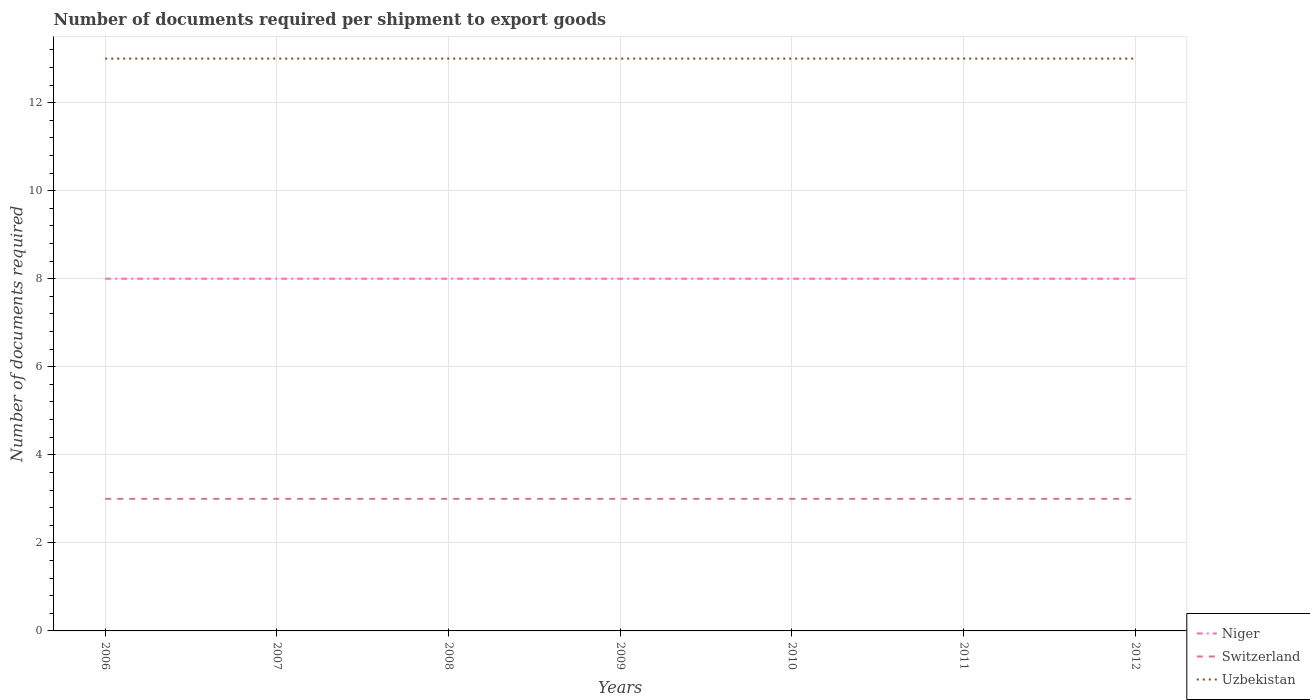How many different coloured lines are there?
Your answer should be compact. 3. Does the line corresponding to Uzbekistan intersect with the line corresponding to Switzerland?
Your response must be concise. No. Is the number of lines equal to the number of legend labels?
Your answer should be very brief. Yes. Across all years, what is the maximum number of documents required per shipment to export goods in Niger?
Ensure brevity in your answer.  8. In which year was the number of documents required per shipment to export goods in Switzerland maximum?
Offer a very short reply. 2006. What is the difference between the highest and the second highest number of documents required per shipment to export goods in Uzbekistan?
Your answer should be compact. 0. How many years are there in the graph?
Your response must be concise. 7. What is the difference between two consecutive major ticks on the Y-axis?
Provide a short and direct response. 2. Does the graph contain grids?
Your answer should be very brief. Yes. How many legend labels are there?
Offer a terse response. 3. What is the title of the graph?
Make the answer very short. Number of documents required per shipment to export goods. Does "Fragile and conflict affected situations" appear as one of the legend labels in the graph?
Offer a terse response. No. What is the label or title of the X-axis?
Provide a short and direct response. Years. What is the label or title of the Y-axis?
Your response must be concise. Number of documents required. What is the Number of documents required of Switzerland in 2006?
Provide a succinct answer. 3. What is the Number of documents required of Niger in 2008?
Offer a terse response. 8. What is the Number of documents required in Switzerland in 2008?
Offer a terse response. 3. What is the Number of documents required of Uzbekistan in 2009?
Your answer should be compact. 13. What is the Number of documents required in Niger in 2010?
Make the answer very short. 8. What is the Number of documents required of Switzerland in 2010?
Ensure brevity in your answer.  3. What is the Number of documents required in Uzbekistan in 2010?
Your answer should be very brief. 13. What is the Number of documents required in Niger in 2011?
Make the answer very short. 8. What is the Number of documents required in Switzerland in 2011?
Your answer should be very brief. 3. What is the Number of documents required in Niger in 2012?
Offer a terse response. 8. What is the Number of documents required of Uzbekistan in 2012?
Your response must be concise. 13. Across all years, what is the maximum Number of documents required of Niger?
Offer a terse response. 8. Across all years, what is the maximum Number of documents required of Uzbekistan?
Provide a short and direct response. 13. Across all years, what is the minimum Number of documents required in Niger?
Your answer should be compact. 8. Across all years, what is the minimum Number of documents required in Uzbekistan?
Give a very brief answer. 13. What is the total Number of documents required in Uzbekistan in the graph?
Your answer should be very brief. 91. What is the difference between the Number of documents required of Niger in 2006 and that in 2007?
Offer a terse response. 0. What is the difference between the Number of documents required of Switzerland in 2006 and that in 2007?
Provide a succinct answer. 0. What is the difference between the Number of documents required in Uzbekistan in 2006 and that in 2008?
Give a very brief answer. 0. What is the difference between the Number of documents required of Uzbekistan in 2006 and that in 2009?
Your response must be concise. 0. What is the difference between the Number of documents required of Uzbekistan in 2006 and that in 2010?
Provide a succinct answer. 0. What is the difference between the Number of documents required in Niger in 2006 and that in 2011?
Keep it short and to the point. 0. What is the difference between the Number of documents required of Uzbekistan in 2006 and that in 2011?
Your response must be concise. 0. What is the difference between the Number of documents required of Niger in 2006 and that in 2012?
Provide a short and direct response. 0. What is the difference between the Number of documents required in Niger in 2007 and that in 2008?
Make the answer very short. 0. What is the difference between the Number of documents required in Uzbekistan in 2007 and that in 2009?
Provide a succinct answer. 0. What is the difference between the Number of documents required of Uzbekistan in 2007 and that in 2010?
Give a very brief answer. 0. What is the difference between the Number of documents required of Switzerland in 2007 and that in 2011?
Offer a very short reply. 0. What is the difference between the Number of documents required in Uzbekistan in 2007 and that in 2012?
Offer a terse response. 0. What is the difference between the Number of documents required of Niger in 2008 and that in 2009?
Give a very brief answer. 0. What is the difference between the Number of documents required of Niger in 2008 and that in 2010?
Provide a succinct answer. 0. What is the difference between the Number of documents required of Uzbekistan in 2008 and that in 2010?
Offer a terse response. 0. What is the difference between the Number of documents required of Niger in 2008 and that in 2011?
Keep it short and to the point. 0. What is the difference between the Number of documents required of Switzerland in 2008 and that in 2011?
Offer a very short reply. 0. What is the difference between the Number of documents required in Uzbekistan in 2008 and that in 2011?
Offer a very short reply. 0. What is the difference between the Number of documents required in Niger in 2008 and that in 2012?
Offer a terse response. 0. What is the difference between the Number of documents required in Switzerland in 2008 and that in 2012?
Your response must be concise. 0. What is the difference between the Number of documents required in Niger in 2009 and that in 2010?
Keep it short and to the point. 0. What is the difference between the Number of documents required in Switzerland in 2009 and that in 2010?
Provide a succinct answer. 0. What is the difference between the Number of documents required in Niger in 2009 and that in 2011?
Your response must be concise. 0. What is the difference between the Number of documents required of Uzbekistan in 2009 and that in 2011?
Offer a very short reply. 0. What is the difference between the Number of documents required in Niger in 2009 and that in 2012?
Offer a very short reply. 0. What is the difference between the Number of documents required in Switzerland in 2009 and that in 2012?
Keep it short and to the point. 0. What is the difference between the Number of documents required of Switzerland in 2010 and that in 2011?
Provide a succinct answer. 0. What is the difference between the Number of documents required in Niger in 2010 and that in 2012?
Offer a terse response. 0. What is the difference between the Number of documents required in Switzerland in 2010 and that in 2012?
Keep it short and to the point. 0. What is the difference between the Number of documents required in Uzbekistan in 2010 and that in 2012?
Your response must be concise. 0. What is the difference between the Number of documents required in Switzerland in 2011 and that in 2012?
Offer a very short reply. 0. What is the difference between the Number of documents required of Uzbekistan in 2011 and that in 2012?
Offer a terse response. 0. What is the difference between the Number of documents required in Niger in 2006 and the Number of documents required in Uzbekistan in 2007?
Ensure brevity in your answer.  -5. What is the difference between the Number of documents required in Niger in 2006 and the Number of documents required in Uzbekistan in 2008?
Give a very brief answer. -5. What is the difference between the Number of documents required in Switzerland in 2006 and the Number of documents required in Uzbekistan in 2008?
Give a very brief answer. -10. What is the difference between the Number of documents required in Niger in 2006 and the Number of documents required in Uzbekistan in 2010?
Keep it short and to the point. -5. What is the difference between the Number of documents required in Switzerland in 2006 and the Number of documents required in Uzbekistan in 2010?
Keep it short and to the point. -10. What is the difference between the Number of documents required of Switzerland in 2006 and the Number of documents required of Uzbekistan in 2011?
Your response must be concise. -10. What is the difference between the Number of documents required in Niger in 2006 and the Number of documents required in Switzerland in 2012?
Keep it short and to the point. 5. What is the difference between the Number of documents required of Niger in 2006 and the Number of documents required of Uzbekistan in 2012?
Ensure brevity in your answer.  -5. What is the difference between the Number of documents required in Switzerland in 2006 and the Number of documents required in Uzbekistan in 2012?
Ensure brevity in your answer.  -10. What is the difference between the Number of documents required in Niger in 2007 and the Number of documents required in Uzbekistan in 2008?
Your answer should be compact. -5. What is the difference between the Number of documents required in Niger in 2007 and the Number of documents required in Switzerland in 2009?
Give a very brief answer. 5. What is the difference between the Number of documents required of Niger in 2007 and the Number of documents required of Uzbekistan in 2009?
Your answer should be compact. -5. What is the difference between the Number of documents required in Niger in 2007 and the Number of documents required in Switzerland in 2011?
Your answer should be compact. 5. What is the difference between the Number of documents required in Switzerland in 2007 and the Number of documents required in Uzbekistan in 2011?
Ensure brevity in your answer.  -10. What is the difference between the Number of documents required in Niger in 2007 and the Number of documents required in Switzerland in 2012?
Give a very brief answer. 5. What is the difference between the Number of documents required in Niger in 2007 and the Number of documents required in Uzbekistan in 2012?
Make the answer very short. -5. What is the difference between the Number of documents required in Switzerland in 2007 and the Number of documents required in Uzbekistan in 2012?
Keep it short and to the point. -10. What is the difference between the Number of documents required of Niger in 2008 and the Number of documents required of Uzbekistan in 2009?
Provide a succinct answer. -5. What is the difference between the Number of documents required of Switzerland in 2008 and the Number of documents required of Uzbekistan in 2009?
Provide a succinct answer. -10. What is the difference between the Number of documents required in Niger in 2008 and the Number of documents required in Switzerland in 2010?
Ensure brevity in your answer.  5. What is the difference between the Number of documents required of Niger in 2008 and the Number of documents required of Uzbekistan in 2010?
Offer a very short reply. -5. What is the difference between the Number of documents required in Switzerland in 2008 and the Number of documents required in Uzbekistan in 2010?
Your answer should be very brief. -10. What is the difference between the Number of documents required in Niger in 2008 and the Number of documents required in Switzerland in 2011?
Make the answer very short. 5. What is the difference between the Number of documents required of Niger in 2008 and the Number of documents required of Uzbekistan in 2011?
Keep it short and to the point. -5. What is the difference between the Number of documents required of Switzerland in 2008 and the Number of documents required of Uzbekistan in 2011?
Ensure brevity in your answer.  -10. What is the difference between the Number of documents required of Niger in 2008 and the Number of documents required of Switzerland in 2012?
Provide a short and direct response. 5. What is the difference between the Number of documents required in Niger in 2008 and the Number of documents required in Uzbekistan in 2012?
Keep it short and to the point. -5. What is the difference between the Number of documents required in Niger in 2009 and the Number of documents required in Switzerland in 2010?
Provide a succinct answer. 5. What is the difference between the Number of documents required in Switzerland in 2009 and the Number of documents required in Uzbekistan in 2010?
Offer a terse response. -10. What is the difference between the Number of documents required in Niger in 2009 and the Number of documents required in Switzerland in 2011?
Your answer should be very brief. 5. What is the difference between the Number of documents required in Niger in 2009 and the Number of documents required in Uzbekistan in 2011?
Provide a succinct answer. -5. What is the difference between the Number of documents required of Switzerland in 2009 and the Number of documents required of Uzbekistan in 2011?
Give a very brief answer. -10. What is the difference between the Number of documents required in Niger in 2009 and the Number of documents required in Switzerland in 2012?
Provide a short and direct response. 5. What is the difference between the Number of documents required of Niger in 2009 and the Number of documents required of Uzbekistan in 2012?
Your answer should be very brief. -5. What is the difference between the Number of documents required in Switzerland in 2009 and the Number of documents required in Uzbekistan in 2012?
Your answer should be compact. -10. What is the difference between the Number of documents required of Niger in 2010 and the Number of documents required of Uzbekistan in 2011?
Offer a very short reply. -5. What is the difference between the Number of documents required in Switzerland in 2010 and the Number of documents required in Uzbekistan in 2012?
Your response must be concise. -10. What is the average Number of documents required of Uzbekistan per year?
Ensure brevity in your answer.  13. In the year 2006, what is the difference between the Number of documents required of Niger and Number of documents required of Switzerland?
Ensure brevity in your answer.  5. In the year 2007, what is the difference between the Number of documents required of Niger and Number of documents required of Switzerland?
Keep it short and to the point. 5. In the year 2007, what is the difference between the Number of documents required of Niger and Number of documents required of Uzbekistan?
Offer a terse response. -5. In the year 2008, what is the difference between the Number of documents required in Niger and Number of documents required in Switzerland?
Keep it short and to the point. 5. In the year 2008, what is the difference between the Number of documents required in Switzerland and Number of documents required in Uzbekistan?
Provide a succinct answer. -10. In the year 2009, what is the difference between the Number of documents required in Niger and Number of documents required in Switzerland?
Offer a terse response. 5. In the year 2009, what is the difference between the Number of documents required of Niger and Number of documents required of Uzbekistan?
Keep it short and to the point. -5. In the year 2009, what is the difference between the Number of documents required in Switzerland and Number of documents required in Uzbekistan?
Ensure brevity in your answer.  -10. In the year 2010, what is the difference between the Number of documents required of Niger and Number of documents required of Switzerland?
Give a very brief answer. 5. In the year 2011, what is the difference between the Number of documents required in Niger and Number of documents required in Uzbekistan?
Make the answer very short. -5. In the year 2011, what is the difference between the Number of documents required of Switzerland and Number of documents required of Uzbekistan?
Keep it short and to the point. -10. In the year 2012, what is the difference between the Number of documents required in Niger and Number of documents required in Switzerland?
Offer a terse response. 5. In the year 2012, what is the difference between the Number of documents required in Switzerland and Number of documents required in Uzbekistan?
Your answer should be compact. -10. What is the ratio of the Number of documents required of Switzerland in 2006 to that in 2007?
Offer a terse response. 1. What is the ratio of the Number of documents required of Uzbekistan in 2006 to that in 2009?
Provide a succinct answer. 1. What is the ratio of the Number of documents required of Switzerland in 2006 to that in 2010?
Your answer should be compact. 1. What is the ratio of the Number of documents required of Uzbekistan in 2006 to that in 2010?
Provide a succinct answer. 1. What is the ratio of the Number of documents required of Switzerland in 2006 to that in 2012?
Provide a short and direct response. 1. What is the ratio of the Number of documents required in Uzbekistan in 2006 to that in 2012?
Make the answer very short. 1. What is the ratio of the Number of documents required in Switzerland in 2007 to that in 2008?
Your answer should be compact. 1. What is the ratio of the Number of documents required of Uzbekistan in 2007 to that in 2008?
Your response must be concise. 1. What is the ratio of the Number of documents required in Uzbekistan in 2007 to that in 2009?
Your answer should be compact. 1. What is the ratio of the Number of documents required of Uzbekistan in 2007 to that in 2011?
Keep it short and to the point. 1. What is the ratio of the Number of documents required of Switzerland in 2008 to that in 2009?
Provide a succinct answer. 1. What is the ratio of the Number of documents required in Uzbekistan in 2008 to that in 2009?
Offer a terse response. 1. What is the ratio of the Number of documents required of Switzerland in 2008 to that in 2010?
Your answer should be very brief. 1. What is the ratio of the Number of documents required of Uzbekistan in 2008 to that in 2011?
Keep it short and to the point. 1. What is the ratio of the Number of documents required in Niger in 2008 to that in 2012?
Your answer should be very brief. 1. What is the ratio of the Number of documents required of Switzerland in 2008 to that in 2012?
Give a very brief answer. 1. What is the ratio of the Number of documents required in Uzbekistan in 2008 to that in 2012?
Make the answer very short. 1. What is the ratio of the Number of documents required in Switzerland in 2009 to that in 2011?
Provide a succinct answer. 1. What is the ratio of the Number of documents required of Uzbekistan in 2009 to that in 2011?
Offer a terse response. 1. What is the ratio of the Number of documents required of Uzbekistan in 2010 to that in 2011?
Give a very brief answer. 1. What is the ratio of the Number of documents required in Niger in 2010 to that in 2012?
Provide a short and direct response. 1. What is the ratio of the Number of documents required of Niger in 2011 to that in 2012?
Offer a very short reply. 1. What is the ratio of the Number of documents required of Uzbekistan in 2011 to that in 2012?
Give a very brief answer. 1. What is the difference between the highest and the second highest Number of documents required of Switzerland?
Your answer should be very brief. 0. What is the difference between the highest and the second highest Number of documents required in Uzbekistan?
Provide a short and direct response. 0. What is the difference between the highest and the lowest Number of documents required in Niger?
Your answer should be compact. 0. What is the difference between the highest and the lowest Number of documents required in Uzbekistan?
Make the answer very short. 0. 